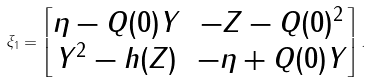Convert formula to latex. <formula><loc_0><loc_0><loc_500><loc_500>\xi _ { 1 } = \begin{bmatrix} \eta - Q ( 0 ) Y & - Z - Q ( 0 ) ^ { 2 } \\ Y ^ { 2 } - h ( Z ) & - \eta + Q ( 0 ) Y \\ \end{bmatrix} .</formula> 